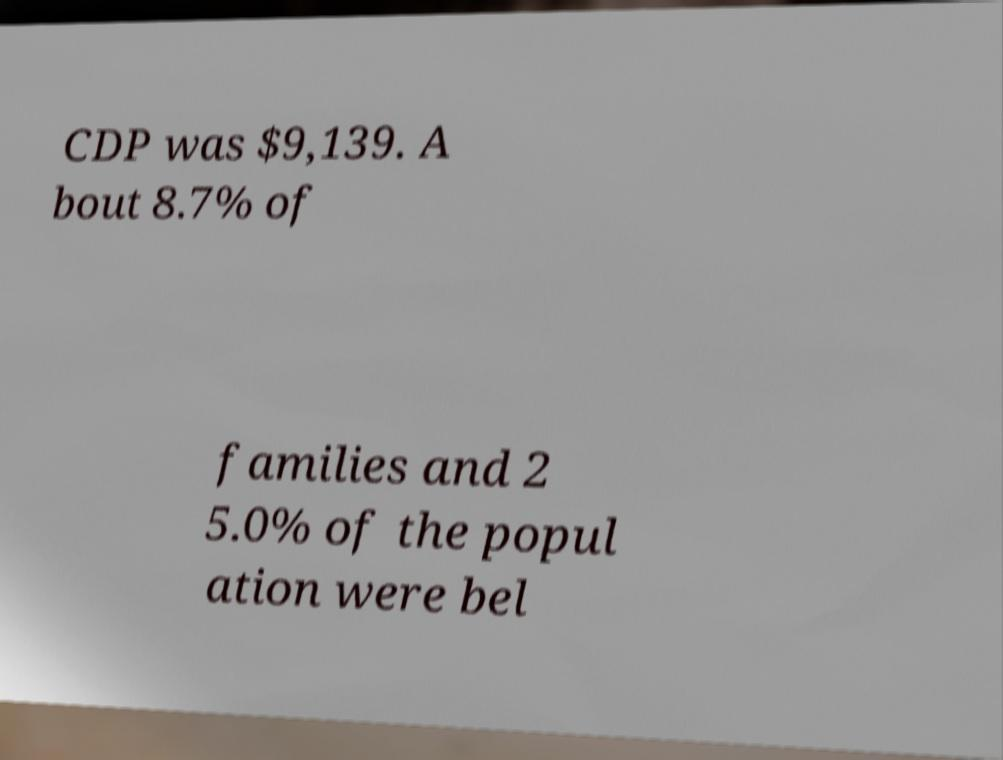Could you extract and type out the text from this image? CDP was $9,139. A bout 8.7% of families and 2 5.0% of the popul ation were bel 